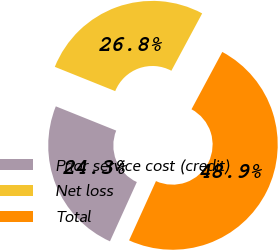Convert chart. <chart><loc_0><loc_0><loc_500><loc_500><pie_chart><fcel>Prior service cost (credit)<fcel>Net loss<fcel>Total<nl><fcel>24.3%<fcel>26.76%<fcel>48.93%<nl></chart> 